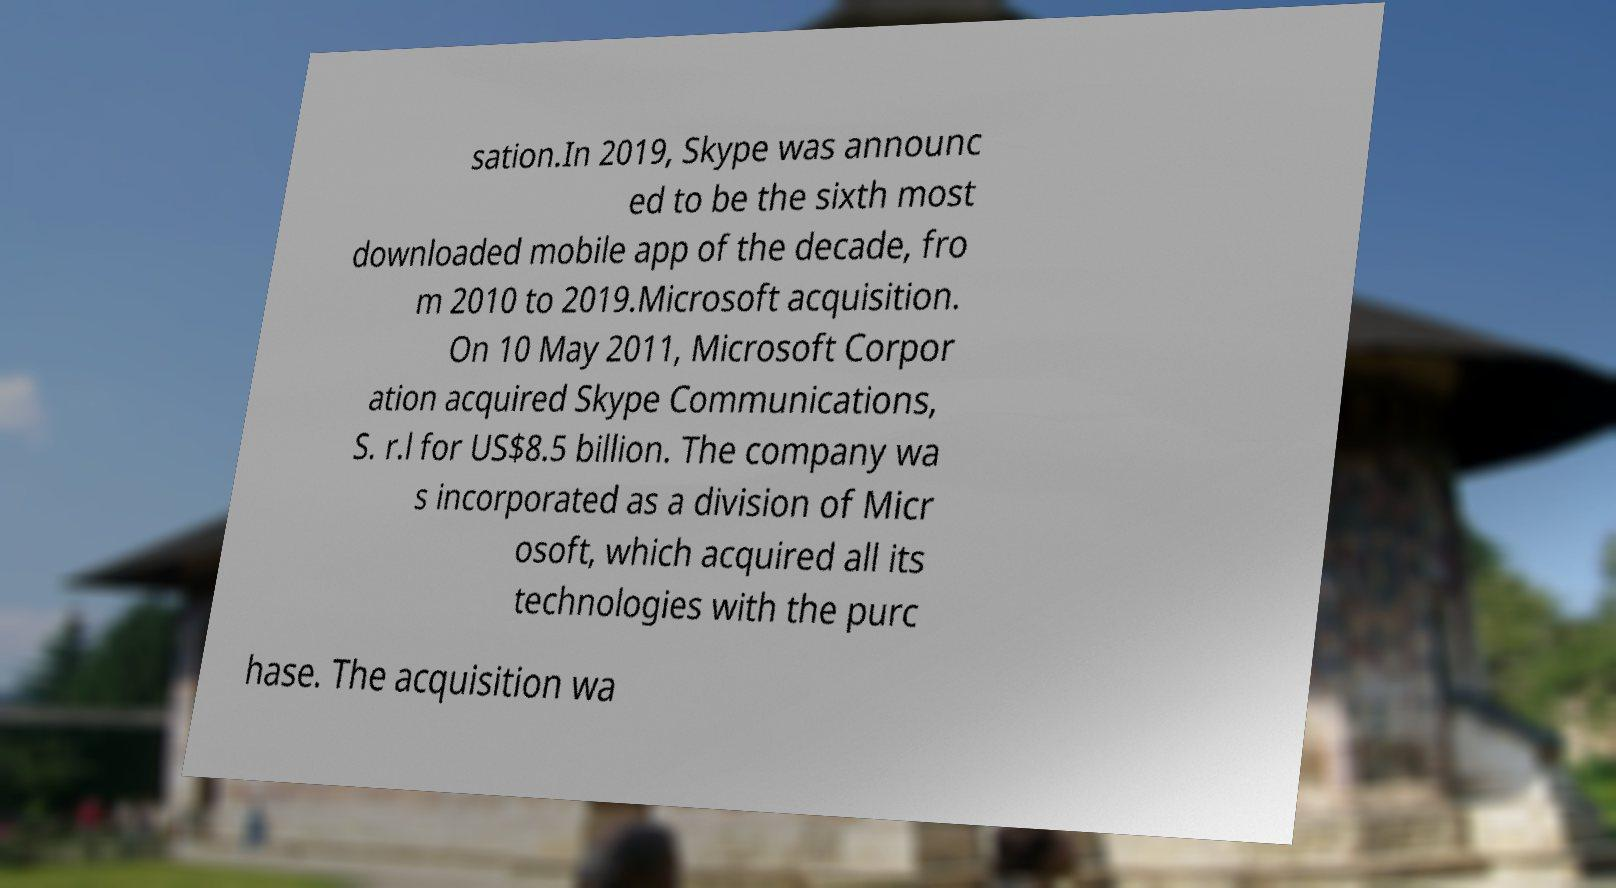Could you extract and type out the text from this image? sation.In 2019, Skype was announc ed to be the sixth most downloaded mobile app of the decade, fro m 2010 to 2019.Microsoft acquisition. On 10 May 2011, Microsoft Corpor ation acquired Skype Communications, S. r.l for US$8.5 billion. The company wa s incorporated as a division of Micr osoft, which acquired all its technologies with the purc hase. The acquisition wa 